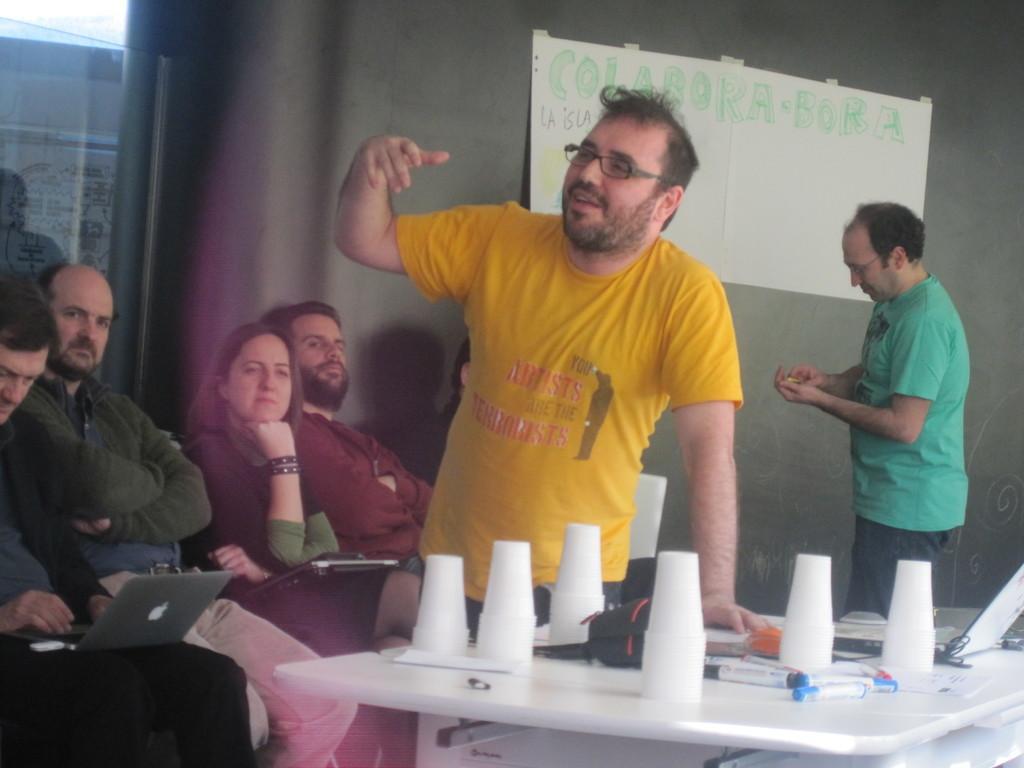How would you summarize this image in a sentence or two? In the center we can see one man is standing,back of him we can see some persons were sitting and observing him. The right side we can see one man is standing. And the front bottom we can see the table on the table few glasses etc. 